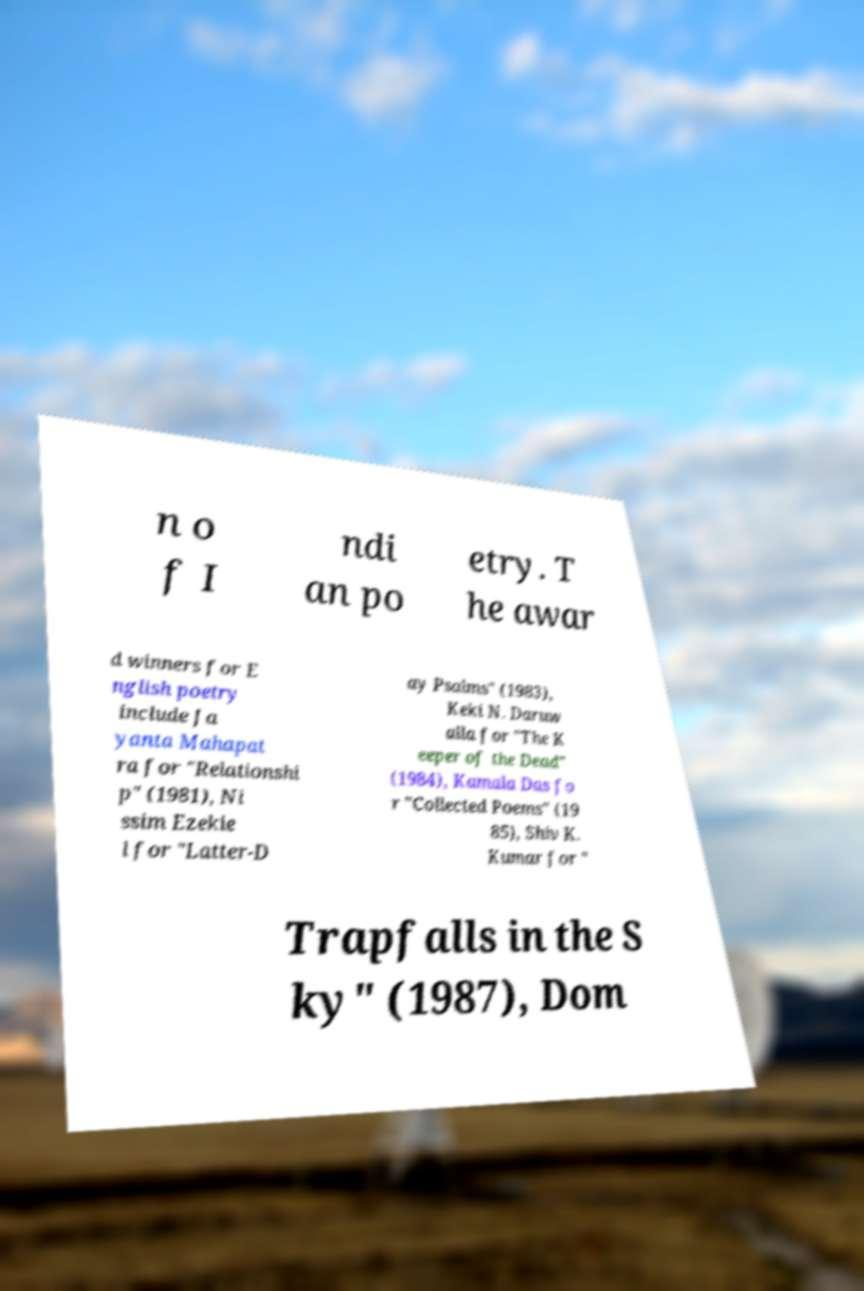What messages or text are displayed in this image? I need them in a readable, typed format. n o f I ndi an po etry. T he awar d winners for E nglish poetry include Ja yanta Mahapat ra for "Relationshi p" (1981), Ni ssim Ezekie l for "Latter-D ay Psalms" (1983), Keki N. Daruw alla for "The K eeper of the Dead" (1984), Kamala Das fo r "Collected Poems" (19 85), Shiv K. Kumar for " Trapfalls in the S ky" (1987), Dom 